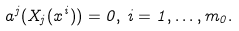<formula> <loc_0><loc_0><loc_500><loc_500>a ^ { j } ( X _ { j } ( x ^ { i } ) ) = 0 , \, i = 1 , \dots , m _ { 0 } .</formula> 